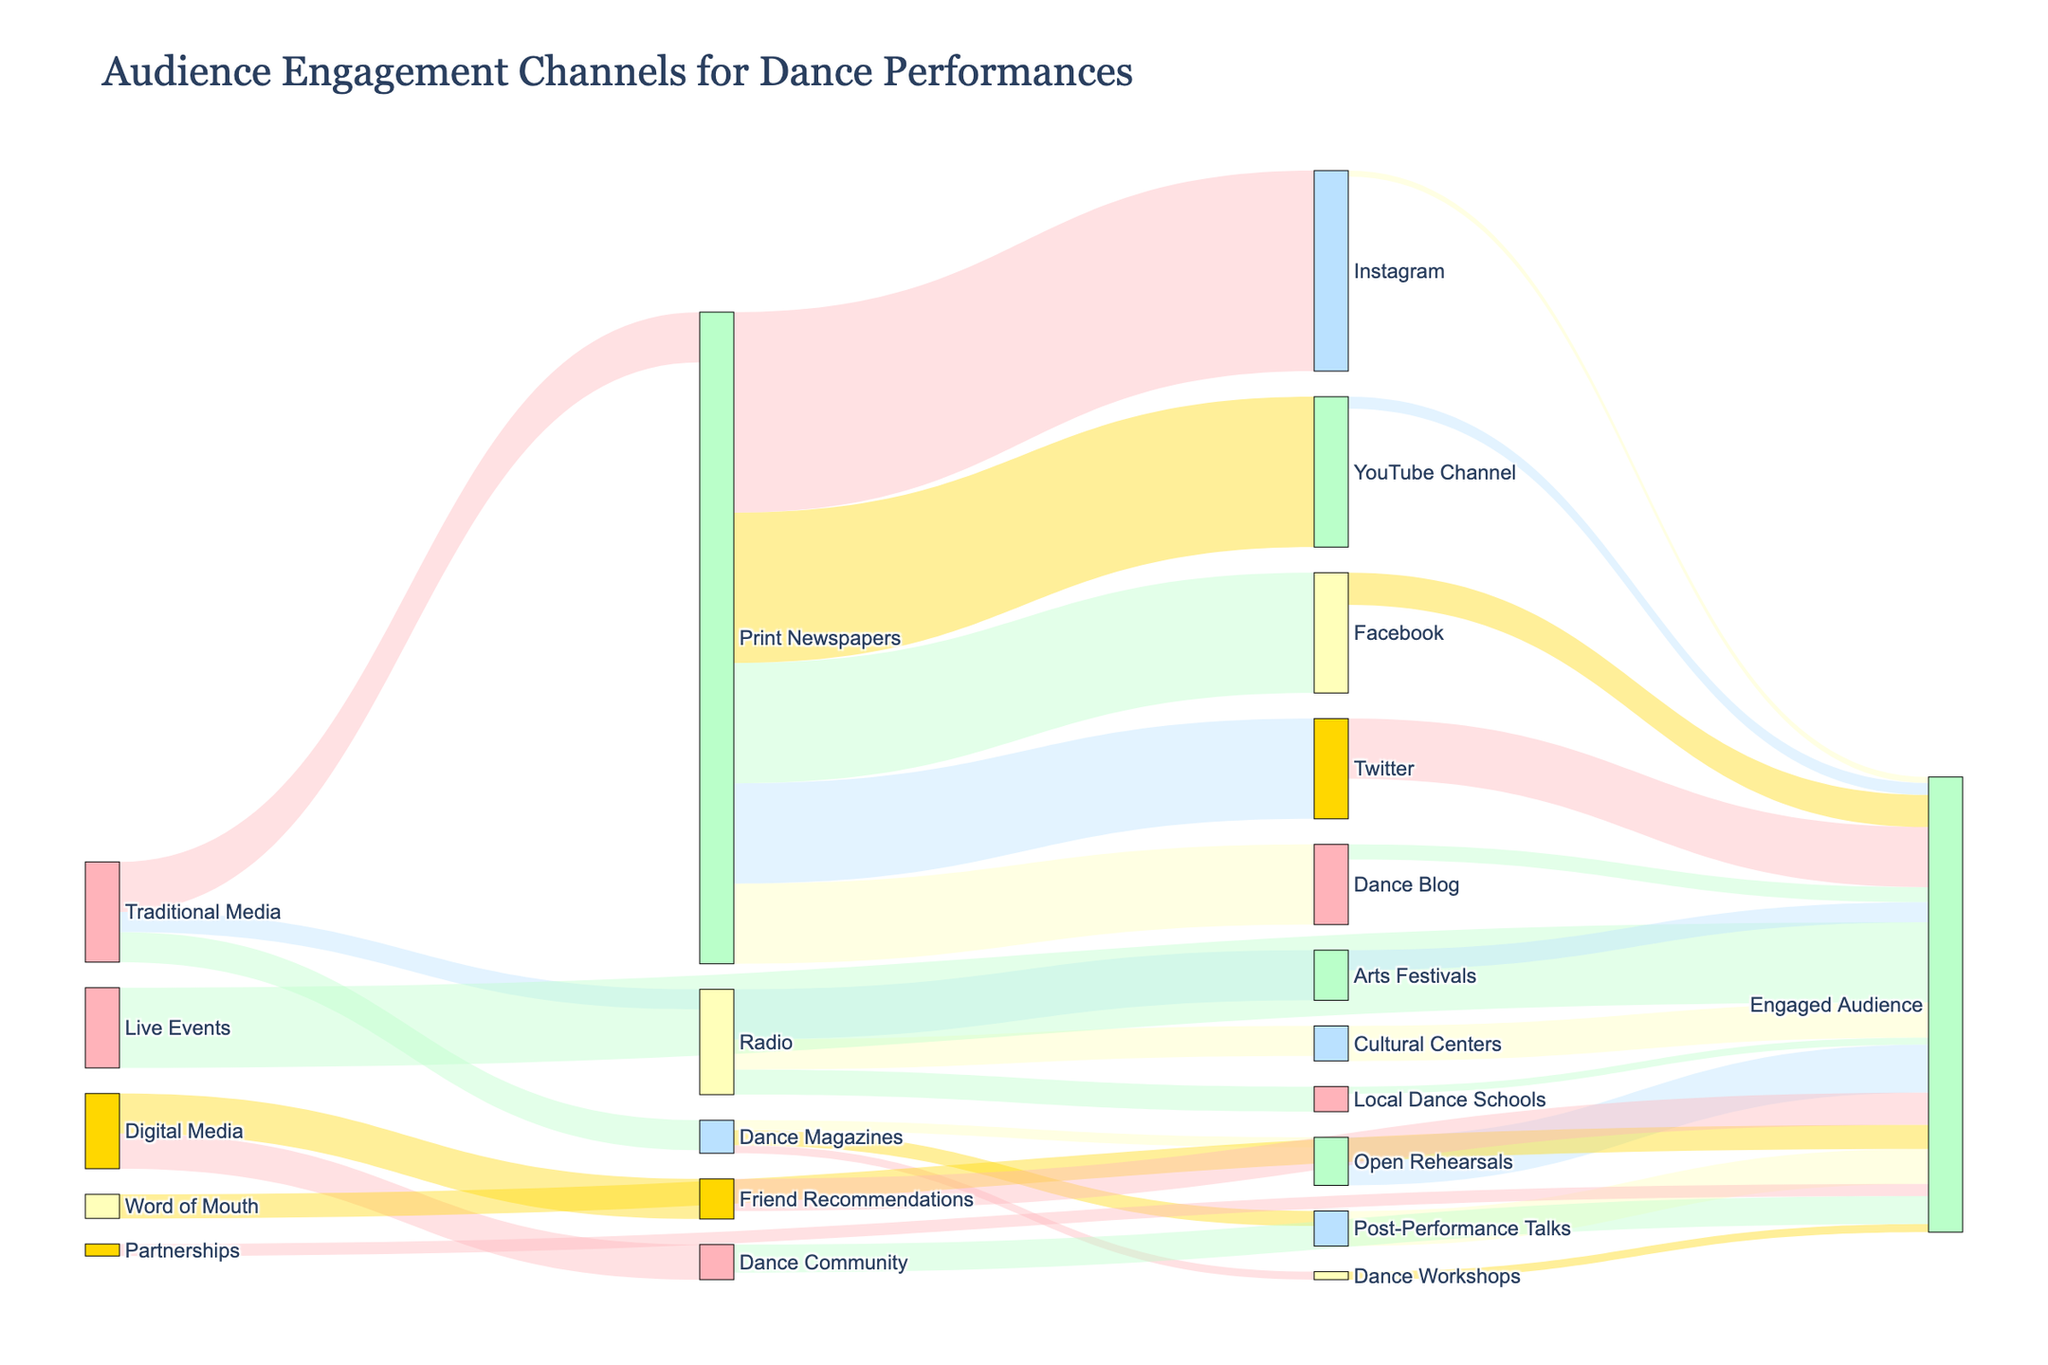What is the total audience from Traditional Media channels? To find the total audience from Traditional Media channels, sum up the audience numbers from Print Newspapers, Dance Magazines, and Radio. This is 5000 + 3000 + 2000.
Answer: 10000 Which channel has the highest engagement? The channel with the highest engagement is identified by the highest value in the Engagement column. Instagram has the highest engagement with 8000.
Answer: Instagram What is the total engaged audience from Digital Media channels? Sum the engagement numbers for all Digital Media sub-channels: Dance Blog (3200), YouTube Channel (6000), Instagram (8000), Facebook (4800), and Twitter (3500).
Answer: 25500 Compare the engagement effectiveness of Live Events and Partnerships. Which one engages a larger audience? Sum the engagement numbers for all channels under Live Events and Partnerships. Live Events: Open Rehearsals (800) + Post-Performance Talks (1200) + Dance Workshops (700) = 2700. Partnerships: Local Dance Schools (2000) + Arts Festivals (3500) + Cultural Centers (2400) = 7900. Partnerships engage a larger audience.
Answer: Partnerships Which source has the smallest audience? Identify the source with the smallest total audience by summing the audience for each source and comparing. Live Events has the smallest with 3300 (1000 + 1500 + 800).
Answer: Live Events How does the engagement from Friend Recommendations compare to that from Dance Community? Compare the engagement numbers of Friend Recommendations (3200) and Dance Community (2800). Friend Recommendations have a higher engagement.
Answer: Friend Recommendations What is the average audience size for Digital Media channels? Sum the audience numbers of all Digital Media channels and divide by the number of channels: (8000 + 15000 + 20000 + 12000 + 10000) / 5.
Answer: 13000 Which channel under Partnerships contributes the least to their total engagement? Compare the engagement numbers of Local Dance Schools (2000), Arts Festivals (3500), and Cultural Centers (2400). Local Dance Schools have the least contribution.
Answer: Local Dance Schools What is the total engaged audience across all sources? Sum all engagement numbers, including each channel across all sources: 1500 + 1200 + 600 + 3200 + 6000 + 8000 + 4800 + 3500 + 800 + 1200 + 700 + 2000 + 3500 + 2400 + 3200 + 2800.
Answer: 41700 Which source has the highest overall engagement? Sum the engagement numbers for each source and compare. Digital Media has the highest overall engagement with a total of 22500 (3200 + 6000 + 8000 + 4800 + 3500).
Answer: Digital Media 